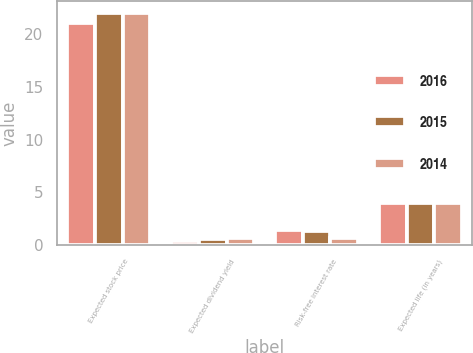<chart> <loc_0><loc_0><loc_500><loc_500><stacked_bar_chart><ecel><fcel>Expected stock price<fcel>Expected dividend yield<fcel>Risk-free interest rate<fcel>Expected life (in years)<nl><fcel>2016<fcel>21<fcel>0.4<fcel>1.4<fcel>4<nl><fcel>2015<fcel>22<fcel>0.6<fcel>1.3<fcel>4<nl><fcel>2014<fcel>22<fcel>0.7<fcel>0.7<fcel>4<nl></chart> 